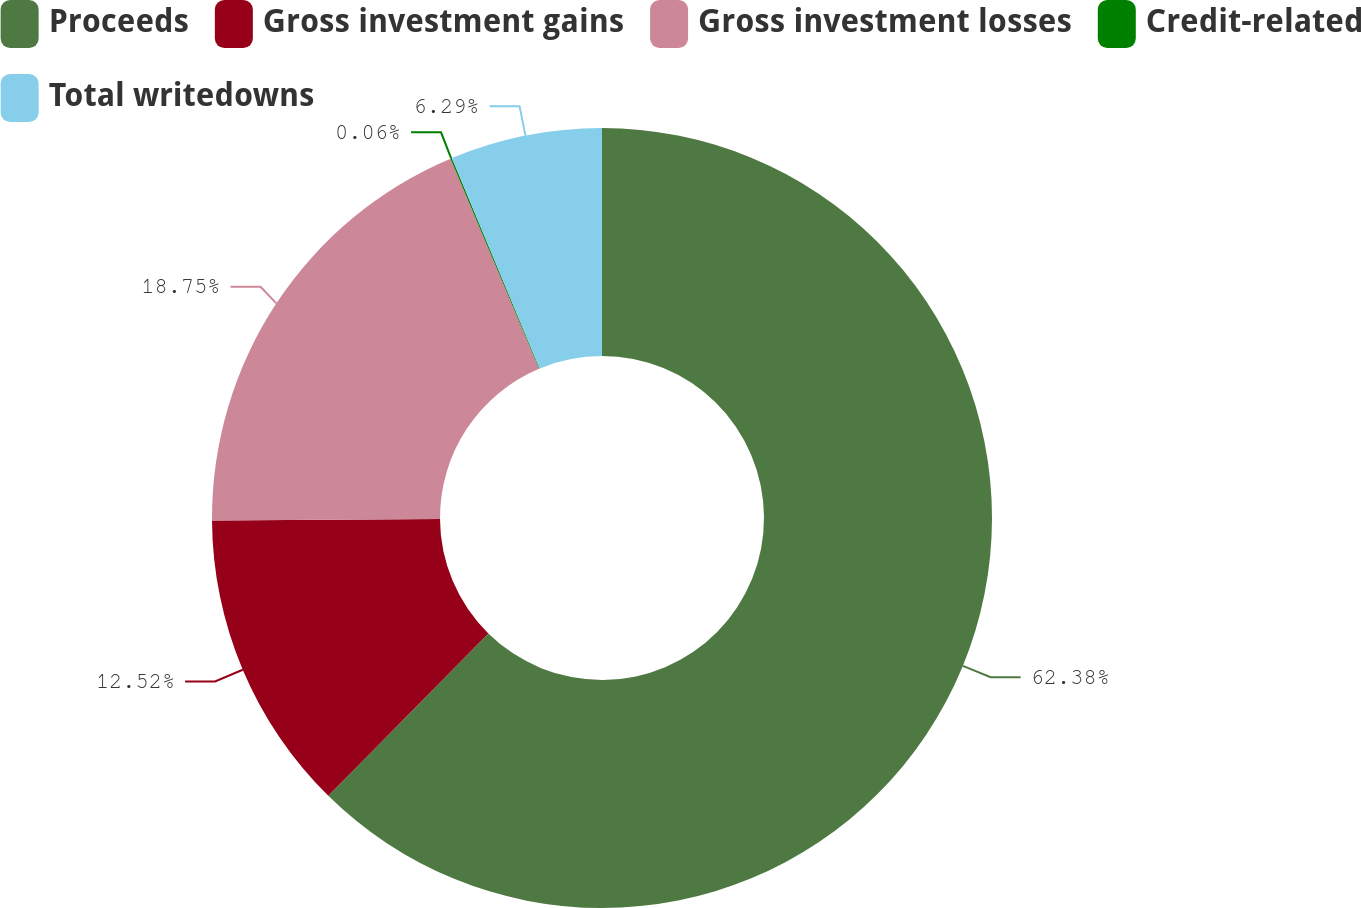<chart> <loc_0><loc_0><loc_500><loc_500><pie_chart><fcel>Proceeds<fcel>Gross investment gains<fcel>Gross investment losses<fcel>Credit-related<fcel>Total writedowns<nl><fcel>62.38%<fcel>12.52%<fcel>18.75%<fcel>0.06%<fcel>6.29%<nl></chart> 